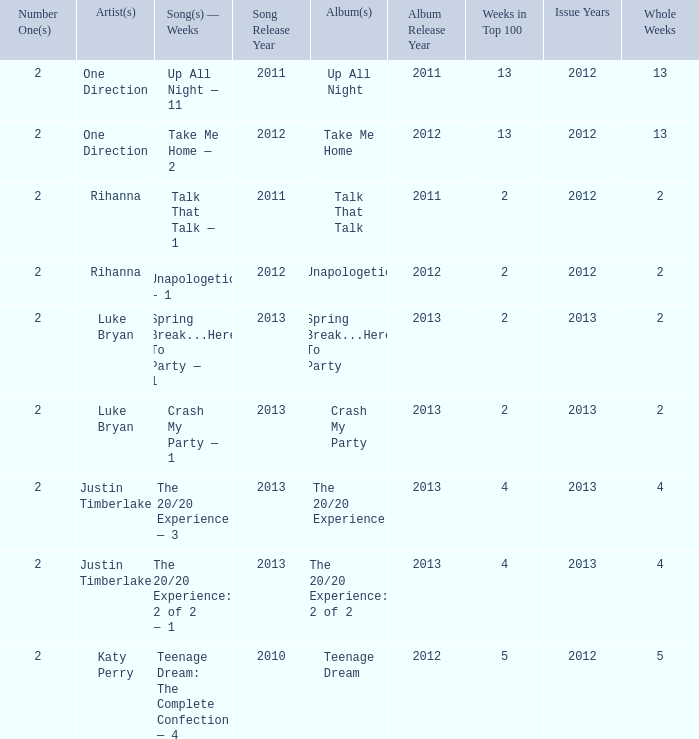What is the longest number of weeks any 1 song was at number #1? 13.0. 